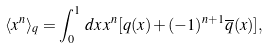<formula> <loc_0><loc_0><loc_500><loc_500>\langle x ^ { n } \rangle _ { q } = \int _ { 0 } ^ { 1 } \, d x \, x ^ { n } [ q ( x ) + ( - 1 ) ^ { n + 1 } \overline { q } ( x ) ] ,</formula> 